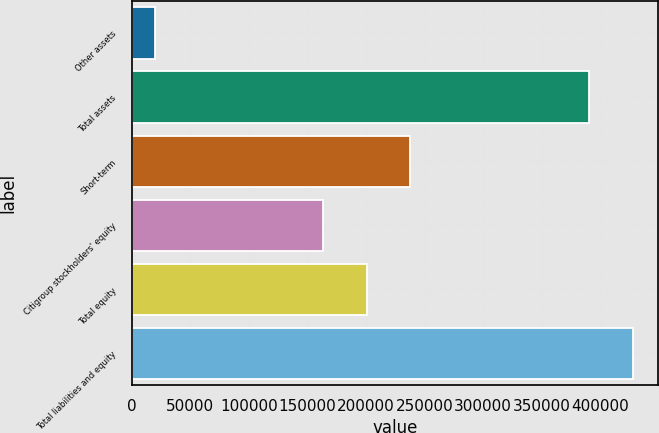<chart> <loc_0><loc_0><loc_500><loc_500><bar_chart><fcel>Other assets<fcel>Total assets<fcel>Short-term<fcel>Citigroup stockholders' equity<fcel>Total equity<fcel>Total liabilities and equity<nl><fcel>19572<fcel>390607<fcel>237675<fcel>163468<fcel>200572<fcel>427710<nl></chart> 